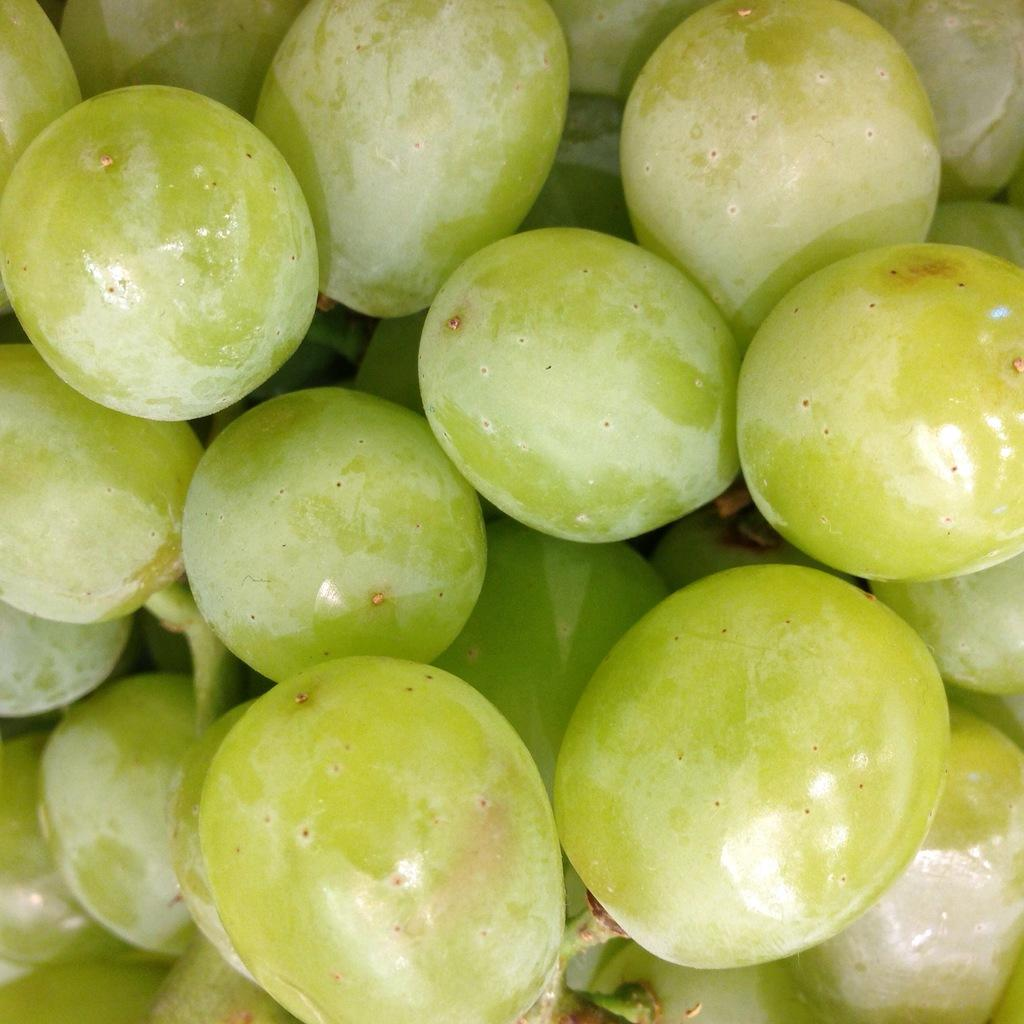What type of fruit is present in the image? There are grapes in the image. What type of glue is used to hold the story together in the image? There is no story or glue present in the image; it only features grapes. 